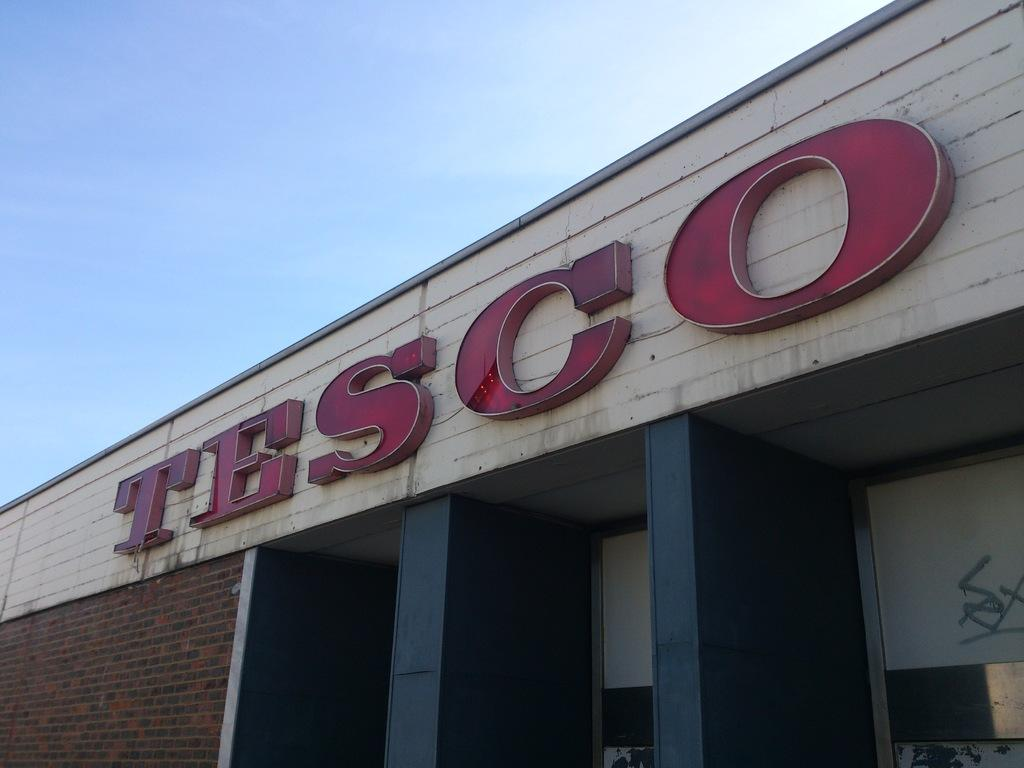What is the main structure visible in the image? There is a building in the image. Can you describe any text or writing on the building? Something is written in red in the image on the building. What can be seen in the background of the image? The sky is visible in the background of the image. What type of food is being served on the cactus in the image? There is no cactus or food present in the image. How many eggs are visible on the building in the image? There are no eggs visible on the building in the image. 